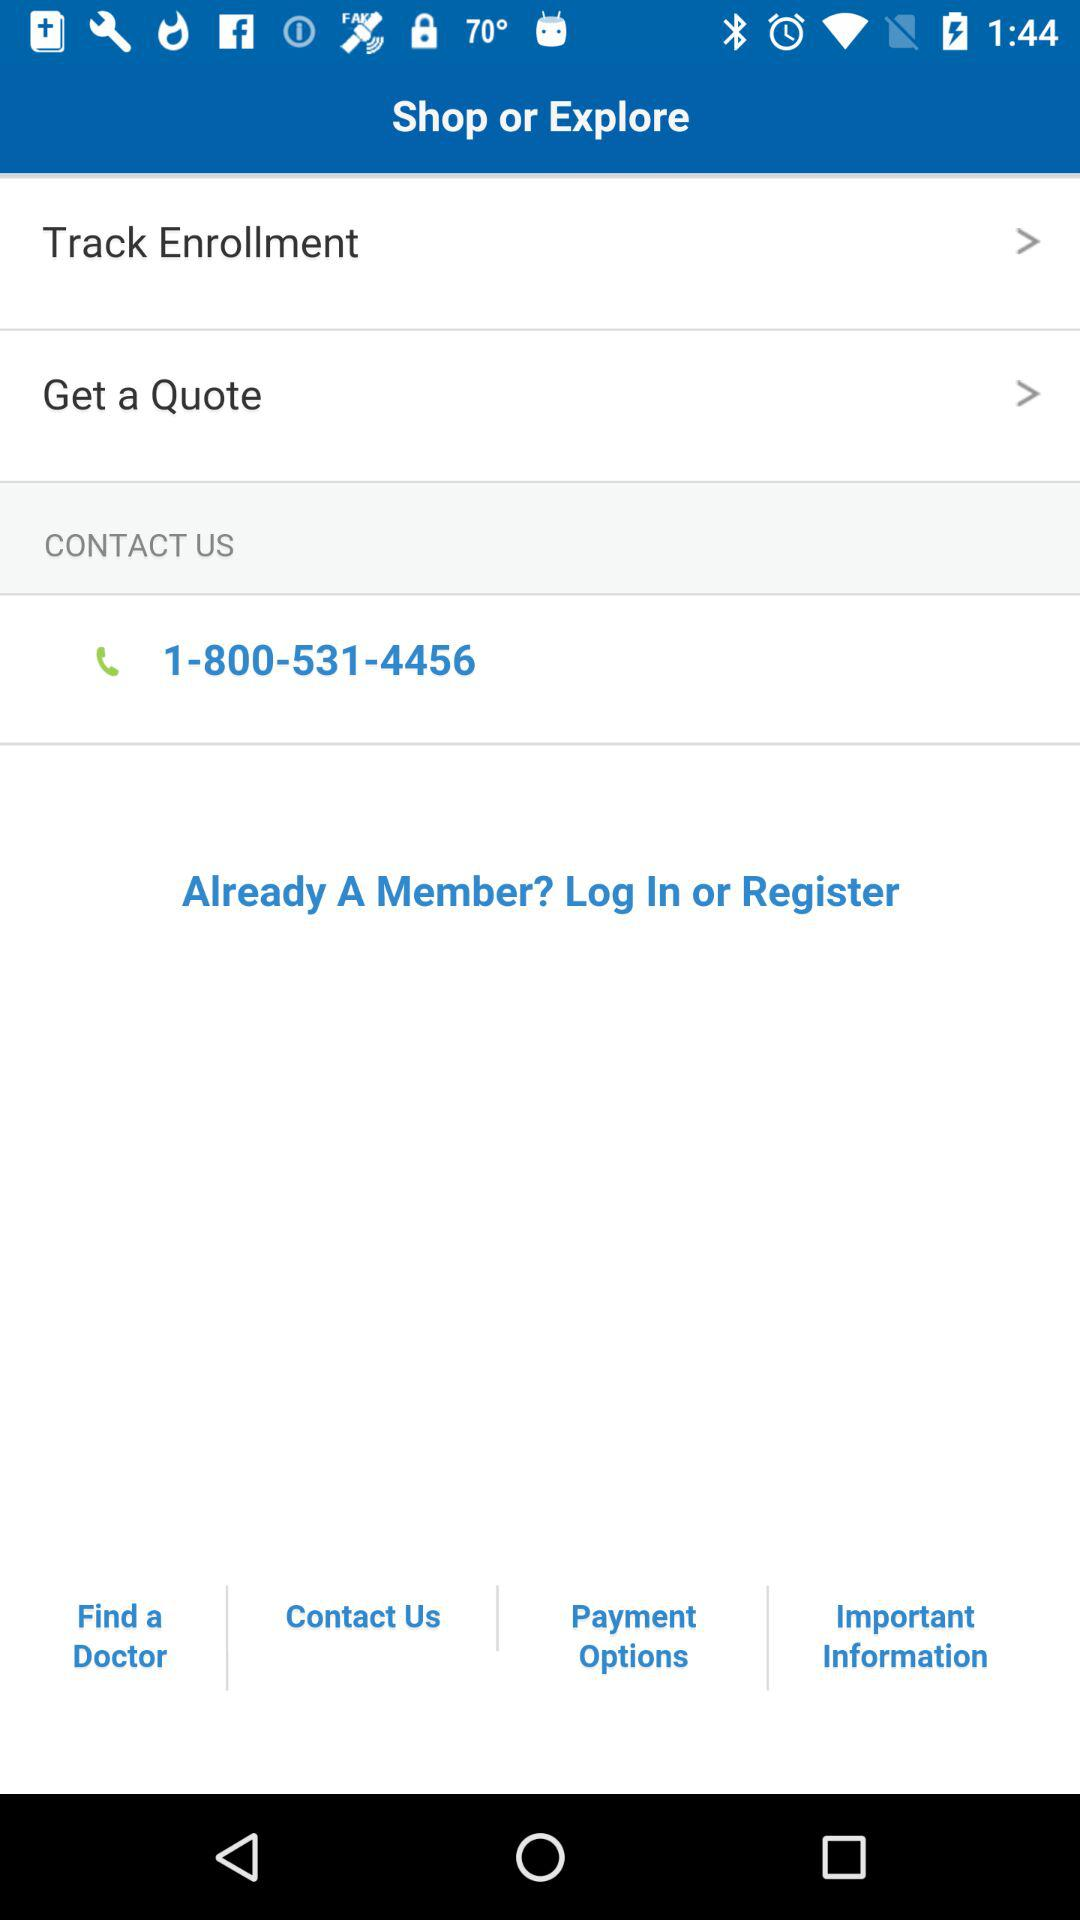What is the number? The number is 1-800-531-4456. 